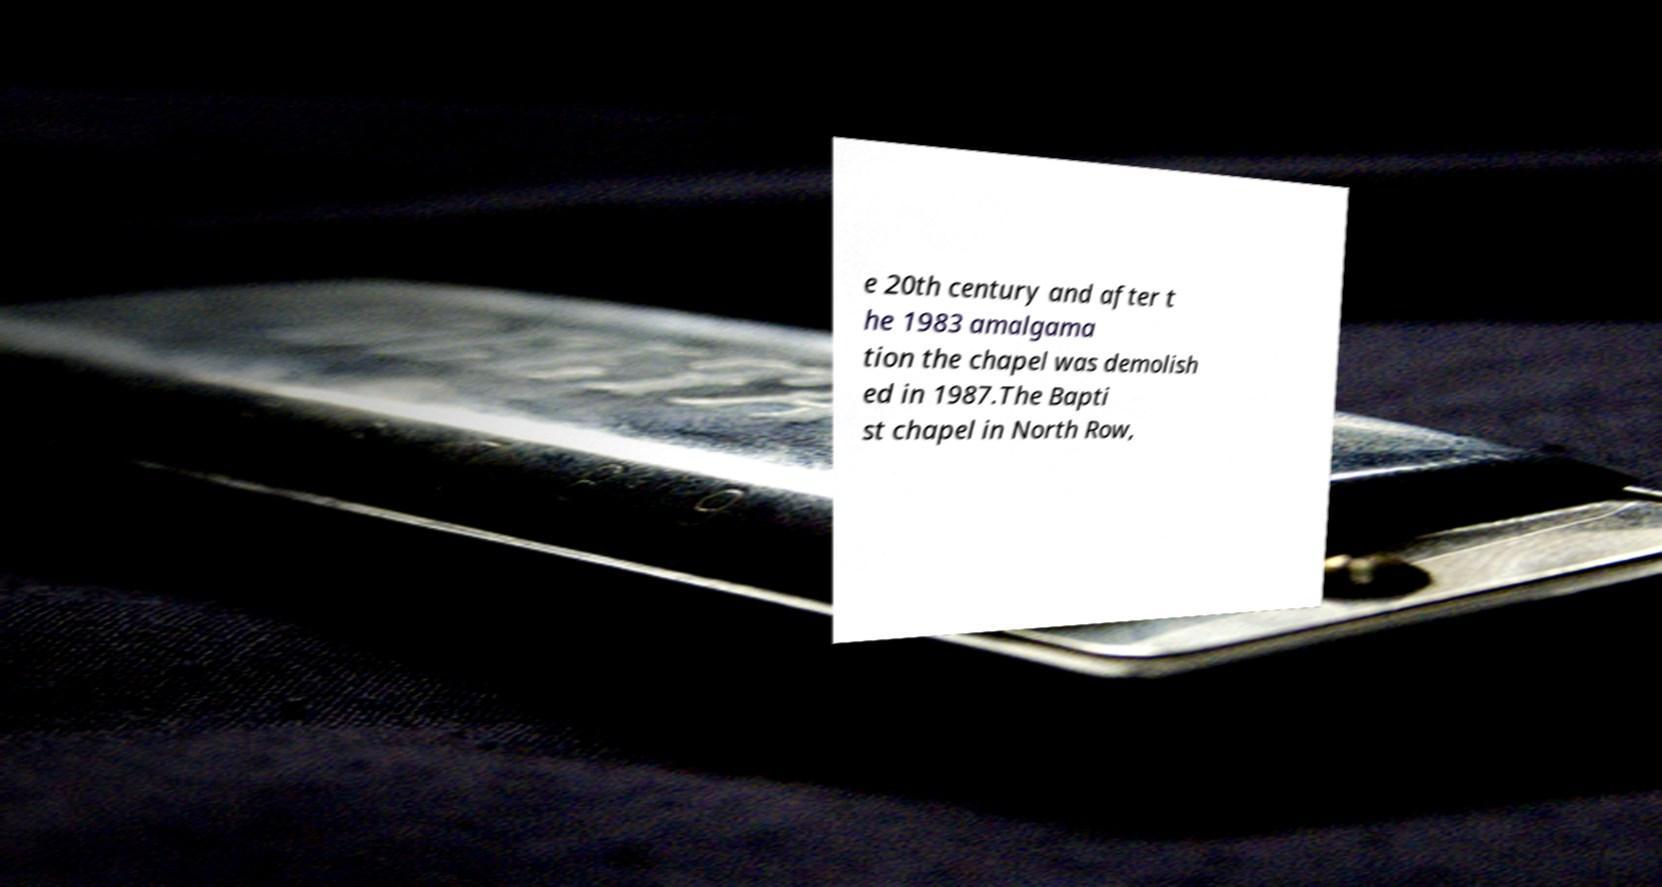Could you assist in decoding the text presented in this image and type it out clearly? e 20th century and after t he 1983 amalgama tion the chapel was demolish ed in 1987.The Bapti st chapel in North Row, 